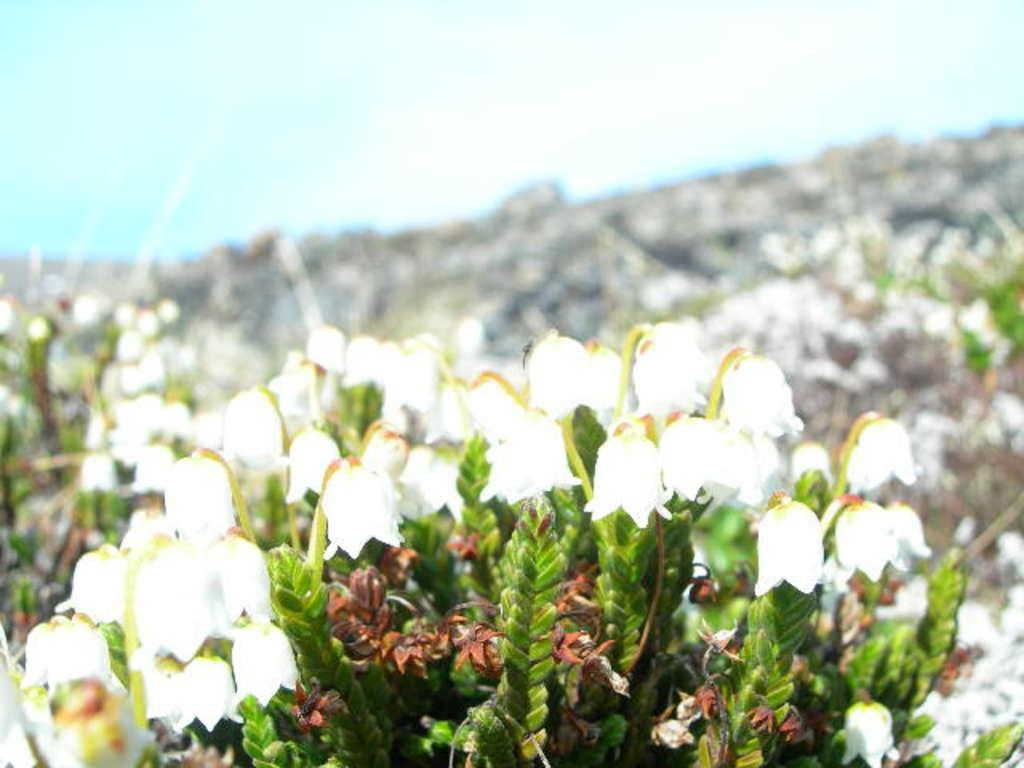What type of living organisms can be seen in the image? Flowers and plants are visible in the image. Can you describe the plants in the image? The plants in the image are not specified, but they are present alongside the flowers. What type of circle can be seen in the image? There is no circle present in the image; it features flowers and plants. What is the view from the top of the tallest plant in the image? The image does not provide a view from the top of any plant, as it is a static representation of flowers and plants. 